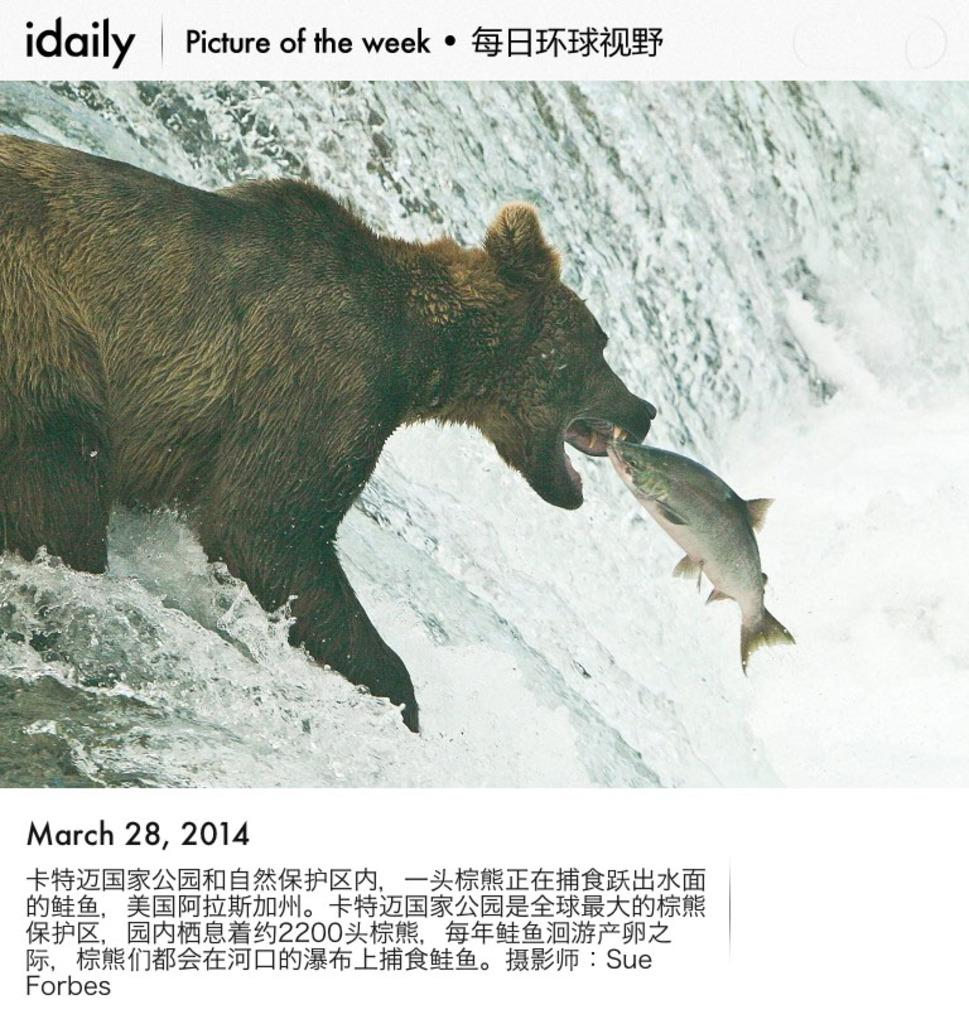What type of animal is in the image? There is an animal in the image, but we cannot determine the specific type from the provided facts. What else is present in the image besides the animal? There are fish and water visible in the image. What is the purpose of the text in the image? The purpose of the text is not clear from the provided facts, but it is likely related to the poster. What type of circle is visible in the image? A: There is no circle present in the image. Can you describe the process of washing dishes in the image? There is no sink or any indication of washing dishes in the image. 